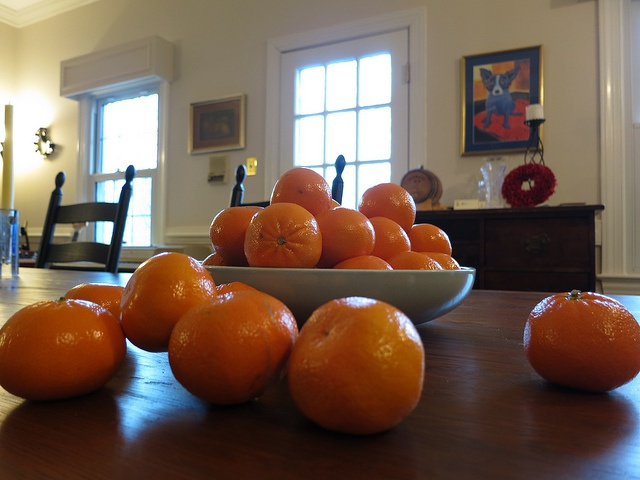Describe the objects in this image and their specific colors. I can see dining table in beige, black, maroon, and brown tones, orange in beige, brown, and maroon tones, orange in beige, maroon, brown, and black tones, orange in beige, maroon, black, and brown tones, and orange in beige, maroon, black, and brown tones in this image. 